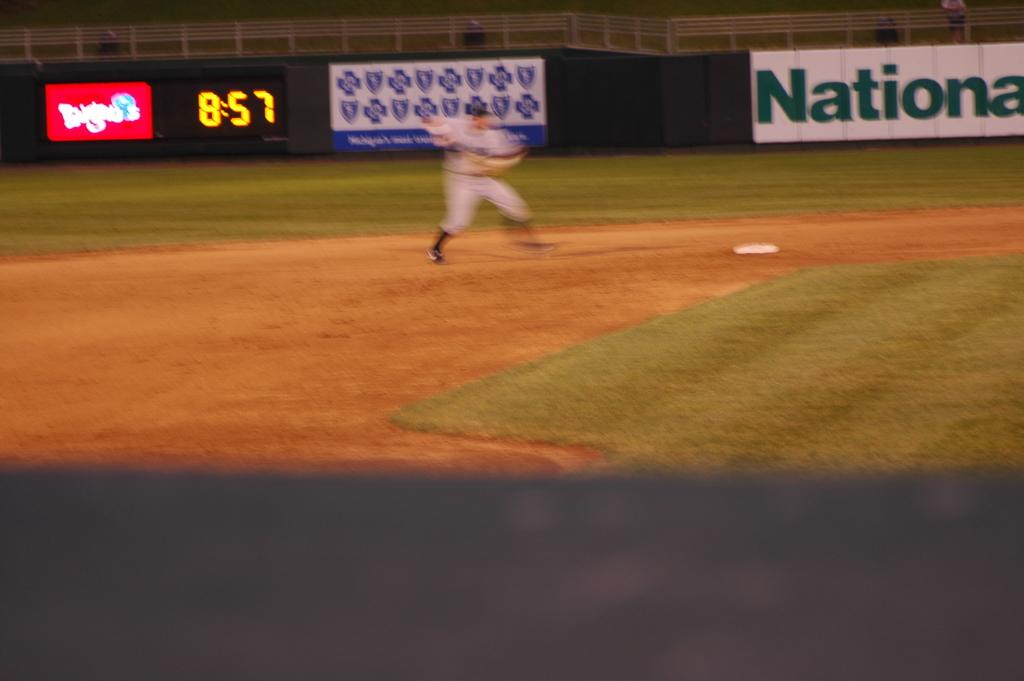<image>
Provide a brief description of the given image. the word national is on the ad next to the field 